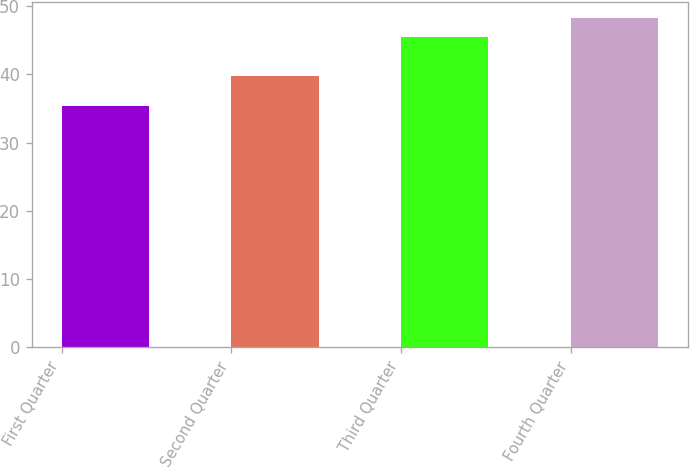<chart> <loc_0><loc_0><loc_500><loc_500><bar_chart><fcel>First Quarter<fcel>Second Quarter<fcel>Third Quarter<fcel>Fourth Quarter<nl><fcel>35.42<fcel>39.68<fcel>45.51<fcel>48.21<nl></chart> 